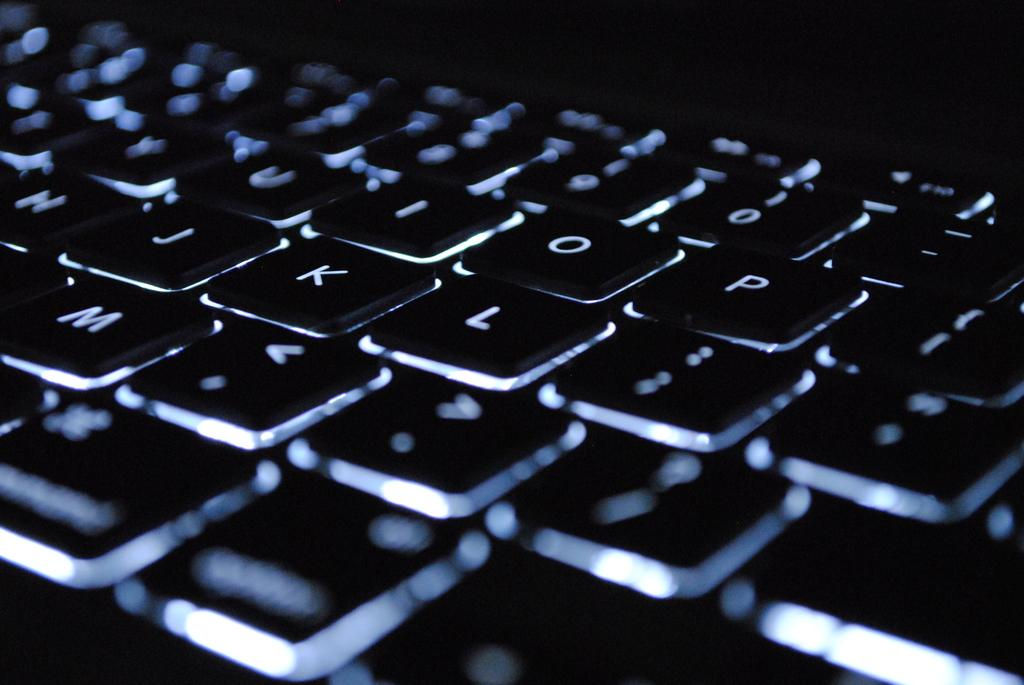<image>
Write a terse but informative summary of the picture. a close up of a black back-lit keyboard has keys like K and L 